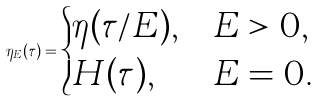<formula> <loc_0><loc_0><loc_500><loc_500>\eta _ { E } ( \tau ) = \begin{cases} \eta ( \tau / E ) , & E > 0 , \\ H ( \tau ) , & E = 0 . \end{cases}</formula> 